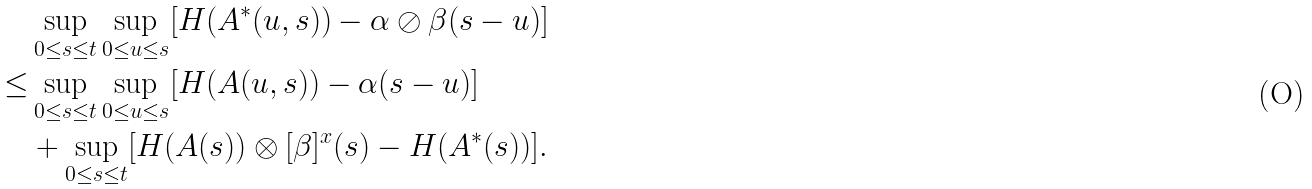<formula> <loc_0><loc_0><loc_500><loc_500>& \sup _ { 0 \leq s \leq t } \sup _ { 0 \leq u \leq s } [ H ( A ^ { * } ( u , s ) ) - \alpha \oslash \beta ( s - u ) ] \\ \leq & \sup _ { 0 \leq s \leq t } \sup _ { 0 \leq u \leq s } [ H ( A ( u , s ) ) - \alpha ( s - u ) ] \\ & + \sup _ { 0 \leq s \leq t } [ H ( A ( s ) ) \otimes [ \beta ] ^ { x } ( s ) - H ( A ^ { * } ( s ) ) ] .</formula> 